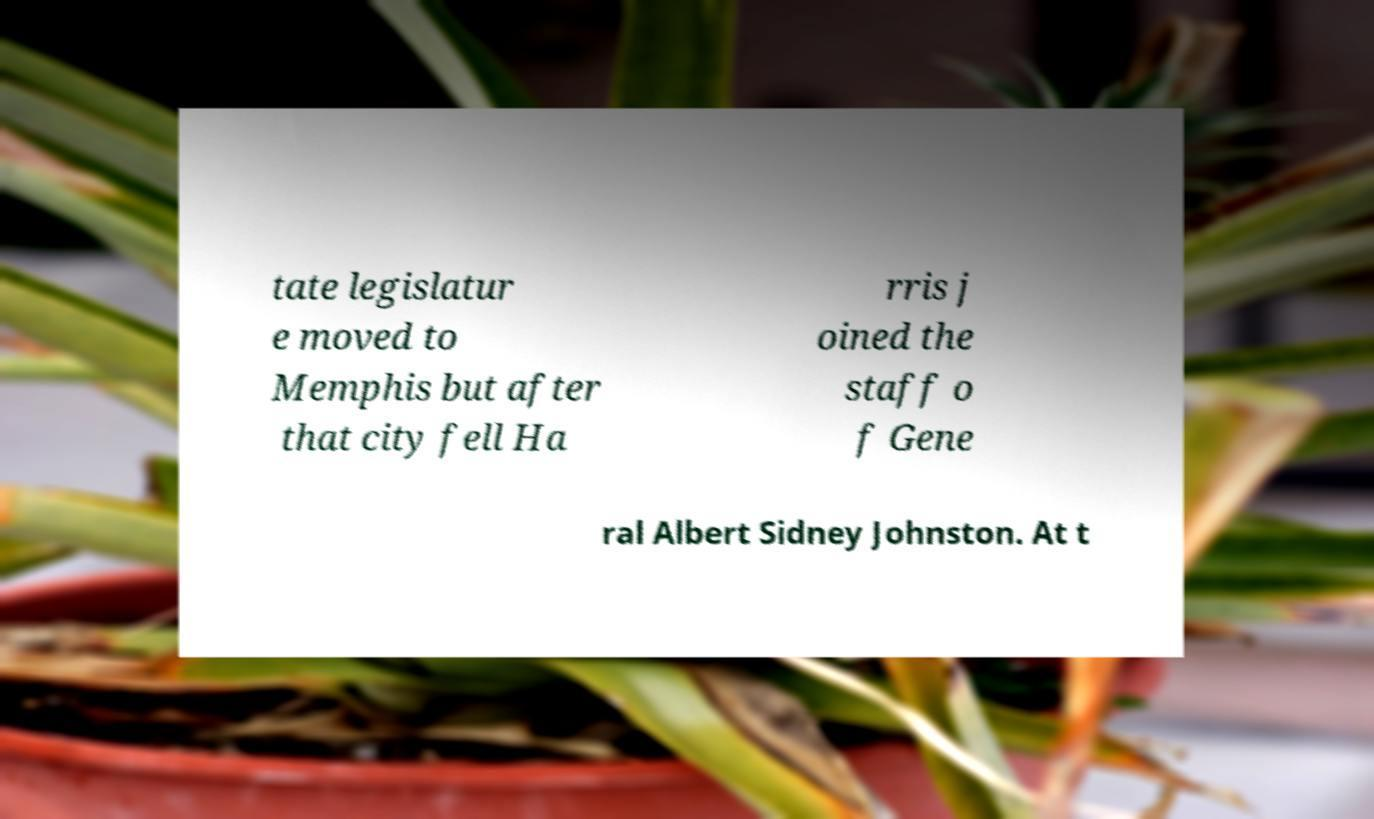Can you accurately transcribe the text from the provided image for me? tate legislatur e moved to Memphis but after that city fell Ha rris j oined the staff o f Gene ral Albert Sidney Johnston. At t 